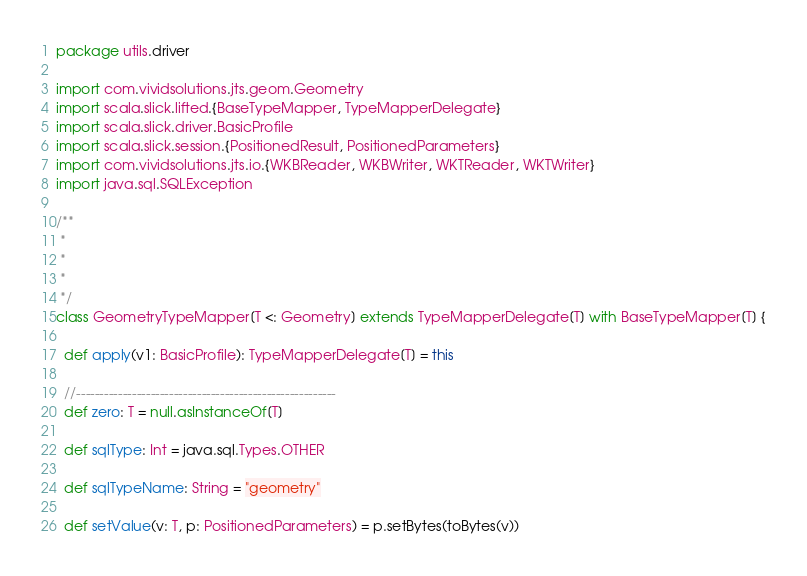<code> <loc_0><loc_0><loc_500><loc_500><_Scala_>package utils.driver

import com.vividsolutions.jts.geom.Geometry
import scala.slick.lifted.{BaseTypeMapper, TypeMapperDelegate}
import scala.slick.driver.BasicProfile
import scala.slick.session.{PositionedResult, PositionedParameters}
import com.vividsolutions.jts.io.{WKBReader, WKBWriter, WKTReader, WKTWriter}
import java.sql.SQLException

/**
 *
 *
 * 
 */
class GeometryTypeMapper[T <: Geometry] extends TypeMapperDelegate[T] with BaseTypeMapper[T] {

  def apply(v1: BasicProfile): TypeMapperDelegate[T] = this

  //--------------------------------------------------------
  def zero: T = null.asInstanceOf[T]

  def sqlType: Int = java.sql.Types.OTHER

  def sqlTypeName: String = "geometry"

  def setValue(v: T, p: PositionedParameters) = p.setBytes(toBytes(v))
</code> 